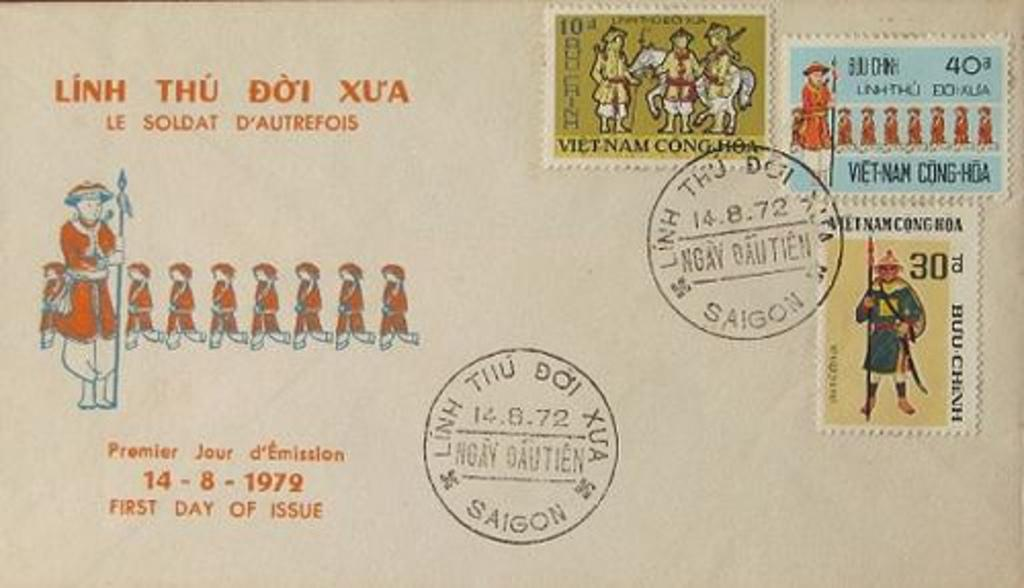<image>
Provide a brief description of the given image. a postcard with the word Linh on it 